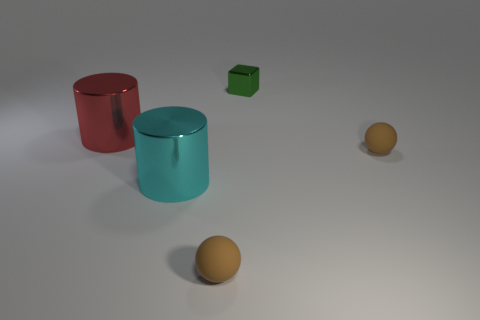How many things are tiny rubber things that are behind the cyan thing or tiny things that are right of the small shiny object?
Give a very brief answer. 1. What number of rubber objects are cyan blocks or red cylinders?
Your answer should be very brief. 0. What is the shape of the cyan metal thing?
Keep it short and to the point. Cylinder. Is the tiny green object made of the same material as the red thing?
Provide a succinct answer. Yes. There is a brown rubber thing that is right of the tiny matte thing left of the tiny green block; is there a small brown matte object in front of it?
Offer a terse response. Yes. What number of other things are there of the same shape as the green shiny object?
Your answer should be compact. 0. There is a metallic object that is behind the large cyan metallic thing and on the left side of the green object; what is its shape?
Provide a short and direct response. Cylinder. What color is the matte thing that is to the right of the small brown ball on the left side of the thing behind the large red thing?
Your answer should be very brief. Brown. Are there more blocks in front of the small shiny block than cyan cylinders that are in front of the big cyan cylinder?
Provide a succinct answer. No. How many other objects are the same size as the cyan thing?
Provide a short and direct response. 1. 